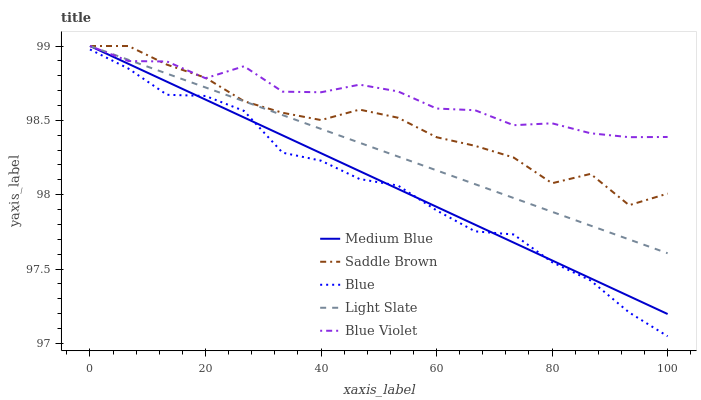Does Blue have the minimum area under the curve?
Answer yes or no. Yes. Does Blue Violet have the maximum area under the curve?
Answer yes or no. Yes. Does Light Slate have the minimum area under the curve?
Answer yes or no. No. Does Light Slate have the maximum area under the curve?
Answer yes or no. No. Is Medium Blue the smoothest?
Answer yes or no. Yes. Is Saddle Brown the roughest?
Answer yes or no. Yes. Is Light Slate the smoothest?
Answer yes or no. No. Is Light Slate the roughest?
Answer yes or no. No. Does Blue have the lowest value?
Answer yes or no. Yes. Does Light Slate have the lowest value?
Answer yes or no. No. Does Blue Violet have the highest value?
Answer yes or no. Yes. Is Blue less than Blue Violet?
Answer yes or no. Yes. Is Blue Violet greater than Blue?
Answer yes or no. Yes. Does Light Slate intersect Medium Blue?
Answer yes or no. Yes. Is Light Slate less than Medium Blue?
Answer yes or no. No. Is Light Slate greater than Medium Blue?
Answer yes or no. No. Does Blue intersect Blue Violet?
Answer yes or no. No. 